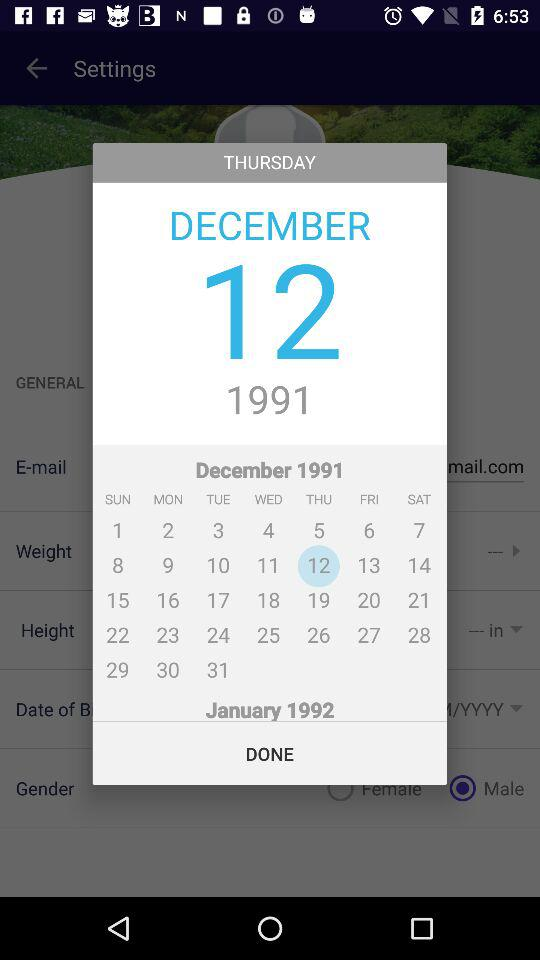Which date is selected? The selected date is Thursday, December 12, 1991. 